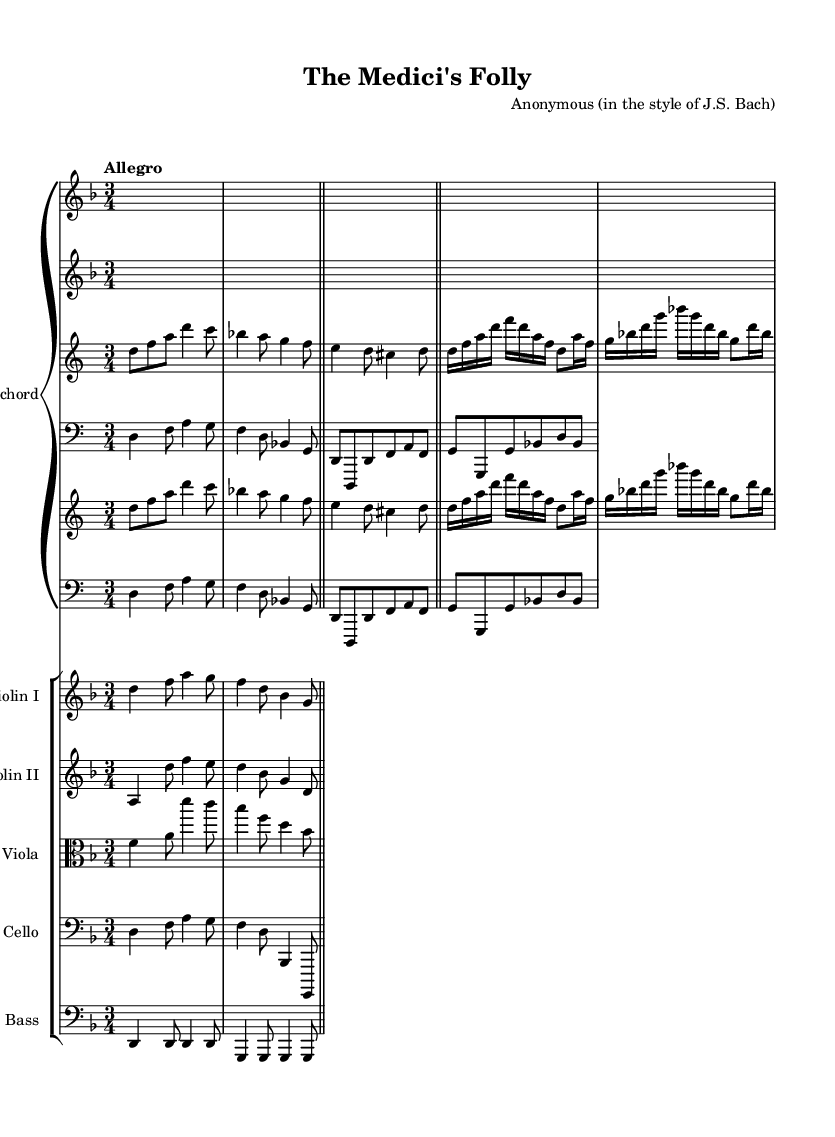What is the key signature of this music? The key signature is indicated by the number of sharps or flats at the beginning of the staff. In this case, it is D minor, which has one flat (B flat).
Answer: D minor What is the time signature of the piece? The time signature is located at the beginning of the staff, indicating how many beats are in each measure. Here, the time signature is 3/4, which means there are three beats per measure.
Answer: 3/4 What is the tempo marking of the harpsichord piece? The tempo marking is written above the staff; it indicates the speed at which the music should be played. In this piece, it is marked "Allegro," indicating a fast tempo.
Answer: Allegro How many measures are in the first section of the harpsichord part? To find the number of measures, count the vertical bar lines that separate the measures. In the harpsichord part, the first section (before the repeat) contains four measures.
Answer: Four Which instruments are included in the score besides the harpsichord? Look at the different staves listed in the score; it contains staves for Violin I, Violin II, Viola, Cello, and Double Bass alongside the harpsichord.
Answer: Violin I, Violin II, Viola, Cello, Double Bass What is the relationship between the harpsichord's right hand and left hand parts? The right hand typically plays the melody while the left hand provides harmonic support or accompaniment. In this piece, both hands interact, but the left hand often complements and fills the harmony.
Answer: Melody and harmony 